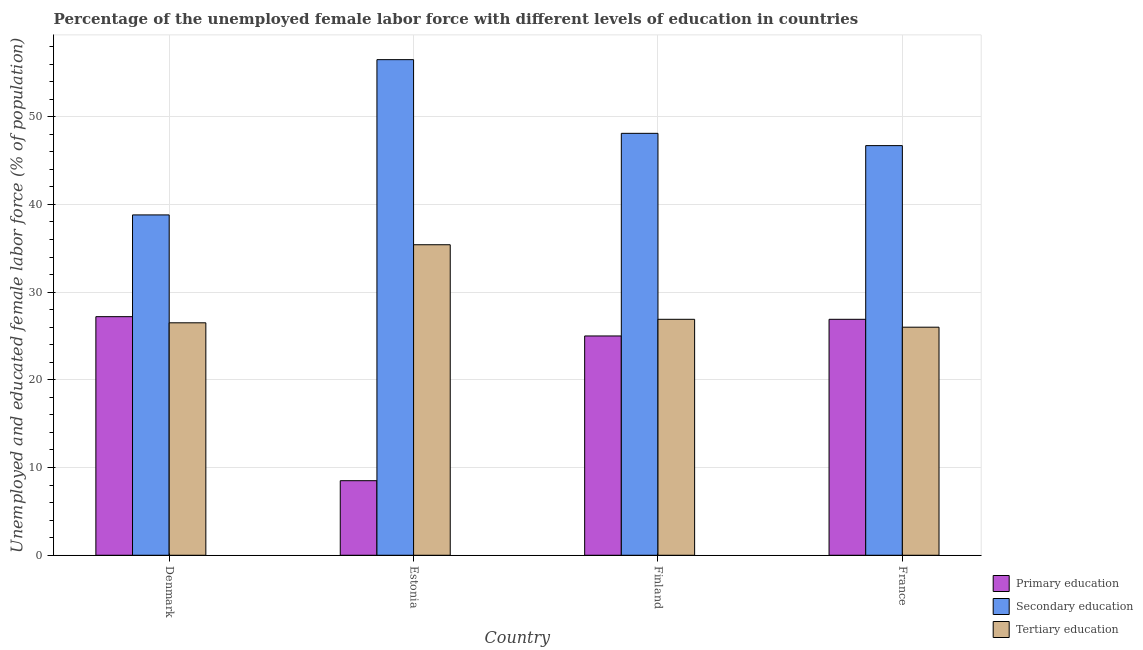Are the number of bars per tick equal to the number of legend labels?
Offer a very short reply. Yes. Are the number of bars on each tick of the X-axis equal?
Your answer should be compact. Yes. What is the label of the 4th group of bars from the left?
Your answer should be compact. France. What is the percentage of female labor force who received secondary education in Estonia?
Ensure brevity in your answer.  56.5. Across all countries, what is the maximum percentage of female labor force who received primary education?
Offer a terse response. 27.2. Across all countries, what is the minimum percentage of female labor force who received secondary education?
Provide a short and direct response. 38.8. In which country was the percentage of female labor force who received secondary education maximum?
Make the answer very short. Estonia. In which country was the percentage of female labor force who received secondary education minimum?
Keep it short and to the point. Denmark. What is the total percentage of female labor force who received primary education in the graph?
Ensure brevity in your answer.  87.6. What is the difference between the percentage of female labor force who received secondary education in Estonia and that in France?
Ensure brevity in your answer.  9.8. What is the difference between the percentage of female labor force who received secondary education in Denmark and the percentage of female labor force who received primary education in Estonia?
Your answer should be very brief. 30.3. What is the average percentage of female labor force who received primary education per country?
Provide a short and direct response. 21.9. What is the difference between the percentage of female labor force who received secondary education and percentage of female labor force who received primary education in Finland?
Provide a succinct answer. 23.1. What is the ratio of the percentage of female labor force who received tertiary education in Estonia to that in France?
Offer a very short reply. 1.36. Is the difference between the percentage of female labor force who received tertiary education in Denmark and Estonia greater than the difference between the percentage of female labor force who received secondary education in Denmark and Estonia?
Your answer should be compact. Yes. What is the difference between the highest and the second highest percentage of female labor force who received primary education?
Provide a succinct answer. 0.3. What is the difference between the highest and the lowest percentage of female labor force who received primary education?
Make the answer very short. 18.7. In how many countries, is the percentage of female labor force who received secondary education greater than the average percentage of female labor force who received secondary education taken over all countries?
Your answer should be compact. 2. Is the sum of the percentage of female labor force who received secondary education in Denmark and France greater than the maximum percentage of female labor force who received primary education across all countries?
Your answer should be compact. Yes. What does the 2nd bar from the left in Estonia represents?
Your answer should be compact. Secondary education. What does the 1st bar from the right in Estonia represents?
Provide a short and direct response. Tertiary education. Is it the case that in every country, the sum of the percentage of female labor force who received primary education and percentage of female labor force who received secondary education is greater than the percentage of female labor force who received tertiary education?
Provide a succinct answer. Yes. Are all the bars in the graph horizontal?
Provide a short and direct response. No. What is the difference between two consecutive major ticks on the Y-axis?
Offer a terse response. 10. Are the values on the major ticks of Y-axis written in scientific E-notation?
Your answer should be very brief. No. Where does the legend appear in the graph?
Offer a very short reply. Bottom right. How many legend labels are there?
Give a very brief answer. 3. How are the legend labels stacked?
Keep it short and to the point. Vertical. What is the title of the graph?
Make the answer very short. Percentage of the unemployed female labor force with different levels of education in countries. Does "Grants" appear as one of the legend labels in the graph?
Provide a short and direct response. No. What is the label or title of the Y-axis?
Offer a terse response. Unemployed and educated female labor force (% of population). What is the Unemployed and educated female labor force (% of population) of Primary education in Denmark?
Provide a succinct answer. 27.2. What is the Unemployed and educated female labor force (% of population) of Secondary education in Denmark?
Give a very brief answer. 38.8. What is the Unemployed and educated female labor force (% of population) in Secondary education in Estonia?
Your response must be concise. 56.5. What is the Unemployed and educated female labor force (% of population) in Tertiary education in Estonia?
Provide a short and direct response. 35.4. What is the Unemployed and educated female labor force (% of population) in Primary education in Finland?
Provide a short and direct response. 25. What is the Unemployed and educated female labor force (% of population) of Secondary education in Finland?
Your response must be concise. 48.1. What is the Unemployed and educated female labor force (% of population) in Tertiary education in Finland?
Ensure brevity in your answer.  26.9. What is the Unemployed and educated female labor force (% of population) in Primary education in France?
Ensure brevity in your answer.  26.9. What is the Unemployed and educated female labor force (% of population) of Secondary education in France?
Offer a terse response. 46.7. What is the Unemployed and educated female labor force (% of population) in Tertiary education in France?
Provide a succinct answer. 26. Across all countries, what is the maximum Unemployed and educated female labor force (% of population) in Primary education?
Provide a succinct answer. 27.2. Across all countries, what is the maximum Unemployed and educated female labor force (% of population) of Secondary education?
Offer a very short reply. 56.5. Across all countries, what is the maximum Unemployed and educated female labor force (% of population) in Tertiary education?
Your response must be concise. 35.4. Across all countries, what is the minimum Unemployed and educated female labor force (% of population) of Primary education?
Keep it short and to the point. 8.5. Across all countries, what is the minimum Unemployed and educated female labor force (% of population) in Secondary education?
Give a very brief answer. 38.8. Across all countries, what is the minimum Unemployed and educated female labor force (% of population) of Tertiary education?
Provide a succinct answer. 26. What is the total Unemployed and educated female labor force (% of population) in Primary education in the graph?
Ensure brevity in your answer.  87.6. What is the total Unemployed and educated female labor force (% of population) of Secondary education in the graph?
Offer a very short reply. 190.1. What is the total Unemployed and educated female labor force (% of population) of Tertiary education in the graph?
Offer a terse response. 114.8. What is the difference between the Unemployed and educated female labor force (% of population) in Primary education in Denmark and that in Estonia?
Provide a succinct answer. 18.7. What is the difference between the Unemployed and educated female labor force (% of population) of Secondary education in Denmark and that in Estonia?
Offer a terse response. -17.7. What is the difference between the Unemployed and educated female labor force (% of population) of Tertiary education in Denmark and that in Estonia?
Ensure brevity in your answer.  -8.9. What is the difference between the Unemployed and educated female labor force (% of population) of Tertiary education in Denmark and that in Finland?
Offer a terse response. -0.4. What is the difference between the Unemployed and educated female labor force (% of population) of Primary education in Denmark and that in France?
Offer a terse response. 0.3. What is the difference between the Unemployed and educated female labor force (% of population) of Tertiary education in Denmark and that in France?
Keep it short and to the point. 0.5. What is the difference between the Unemployed and educated female labor force (% of population) in Primary education in Estonia and that in Finland?
Provide a short and direct response. -16.5. What is the difference between the Unemployed and educated female labor force (% of population) of Secondary education in Estonia and that in Finland?
Offer a terse response. 8.4. What is the difference between the Unemployed and educated female labor force (% of population) of Tertiary education in Estonia and that in Finland?
Your answer should be compact. 8.5. What is the difference between the Unemployed and educated female labor force (% of population) of Primary education in Estonia and that in France?
Provide a short and direct response. -18.4. What is the difference between the Unemployed and educated female labor force (% of population) of Tertiary education in Estonia and that in France?
Your response must be concise. 9.4. What is the difference between the Unemployed and educated female labor force (% of population) of Primary education in Finland and that in France?
Keep it short and to the point. -1.9. What is the difference between the Unemployed and educated female labor force (% of population) in Secondary education in Finland and that in France?
Your answer should be compact. 1.4. What is the difference between the Unemployed and educated female labor force (% of population) of Primary education in Denmark and the Unemployed and educated female labor force (% of population) of Secondary education in Estonia?
Ensure brevity in your answer.  -29.3. What is the difference between the Unemployed and educated female labor force (% of population) in Secondary education in Denmark and the Unemployed and educated female labor force (% of population) in Tertiary education in Estonia?
Offer a very short reply. 3.4. What is the difference between the Unemployed and educated female labor force (% of population) in Primary education in Denmark and the Unemployed and educated female labor force (% of population) in Secondary education in Finland?
Offer a very short reply. -20.9. What is the difference between the Unemployed and educated female labor force (% of population) in Primary education in Denmark and the Unemployed and educated female labor force (% of population) in Tertiary education in Finland?
Your response must be concise. 0.3. What is the difference between the Unemployed and educated female labor force (% of population) of Secondary education in Denmark and the Unemployed and educated female labor force (% of population) of Tertiary education in Finland?
Offer a very short reply. 11.9. What is the difference between the Unemployed and educated female labor force (% of population) in Primary education in Denmark and the Unemployed and educated female labor force (% of population) in Secondary education in France?
Your response must be concise. -19.5. What is the difference between the Unemployed and educated female labor force (% of population) in Primary education in Denmark and the Unemployed and educated female labor force (% of population) in Tertiary education in France?
Give a very brief answer. 1.2. What is the difference between the Unemployed and educated female labor force (% of population) in Primary education in Estonia and the Unemployed and educated female labor force (% of population) in Secondary education in Finland?
Keep it short and to the point. -39.6. What is the difference between the Unemployed and educated female labor force (% of population) of Primary education in Estonia and the Unemployed and educated female labor force (% of population) of Tertiary education in Finland?
Make the answer very short. -18.4. What is the difference between the Unemployed and educated female labor force (% of population) of Secondary education in Estonia and the Unemployed and educated female labor force (% of population) of Tertiary education in Finland?
Give a very brief answer. 29.6. What is the difference between the Unemployed and educated female labor force (% of population) of Primary education in Estonia and the Unemployed and educated female labor force (% of population) of Secondary education in France?
Give a very brief answer. -38.2. What is the difference between the Unemployed and educated female labor force (% of population) in Primary education in Estonia and the Unemployed and educated female labor force (% of population) in Tertiary education in France?
Your answer should be very brief. -17.5. What is the difference between the Unemployed and educated female labor force (% of population) in Secondary education in Estonia and the Unemployed and educated female labor force (% of population) in Tertiary education in France?
Provide a short and direct response. 30.5. What is the difference between the Unemployed and educated female labor force (% of population) in Primary education in Finland and the Unemployed and educated female labor force (% of population) in Secondary education in France?
Make the answer very short. -21.7. What is the difference between the Unemployed and educated female labor force (% of population) of Primary education in Finland and the Unemployed and educated female labor force (% of population) of Tertiary education in France?
Provide a succinct answer. -1. What is the difference between the Unemployed and educated female labor force (% of population) in Secondary education in Finland and the Unemployed and educated female labor force (% of population) in Tertiary education in France?
Keep it short and to the point. 22.1. What is the average Unemployed and educated female labor force (% of population) in Primary education per country?
Ensure brevity in your answer.  21.9. What is the average Unemployed and educated female labor force (% of population) in Secondary education per country?
Give a very brief answer. 47.52. What is the average Unemployed and educated female labor force (% of population) in Tertiary education per country?
Offer a very short reply. 28.7. What is the difference between the Unemployed and educated female labor force (% of population) of Primary education and Unemployed and educated female labor force (% of population) of Secondary education in Estonia?
Offer a terse response. -48. What is the difference between the Unemployed and educated female labor force (% of population) in Primary education and Unemployed and educated female labor force (% of population) in Tertiary education in Estonia?
Keep it short and to the point. -26.9. What is the difference between the Unemployed and educated female labor force (% of population) of Secondary education and Unemployed and educated female labor force (% of population) of Tertiary education in Estonia?
Offer a terse response. 21.1. What is the difference between the Unemployed and educated female labor force (% of population) in Primary education and Unemployed and educated female labor force (% of population) in Secondary education in Finland?
Make the answer very short. -23.1. What is the difference between the Unemployed and educated female labor force (% of population) of Primary education and Unemployed and educated female labor force (% of population) of Tertiary education in Finland?
Your answer should be very brief. -1.9. What is the difference between the Unemployed and educated female labor force (% of population) of Secondary education and Unemployed and educated female labor force (% of population) of Tertiary education in Finland?
Your response must be concise. 21.2. What is the difference between the Unemployed and educated female labor force (% of population) of Primary education and Unemployed and educated female labor force (% of population) of Secondary education in France?
Your response must be concise. -19.8. What is the difference between the Unemployed and educated female labor force (% of population) in Primary education and Unemployed and educated female labor force (% of population) in Tertiary education in France?
Make the answer very short. 0.9. What is the difference between the Unemployed and educated female labor force (% of population) in Secondary education and Unemployed and educated female labor force (% of population) in Tertiary education in France?
Provide a short and direct response. 20.7. What is the ratio of the Unemployed and educated female labor force (% of population) of Secondary education in Denmark to that in Estonia?
Provide a short and direct response. 0.69. What is the ratio of the Unemployed and educated female labor force (% of population) in Tertiary education in Denmark to that in Estonia?
Make the answer very short. 0.75. What is the ratio of the Unemployed and educated female labor force (% of population) of Primary education in Denmark to that in Finland?
Provide a succinct answer. 1.09. What is the ratio of the Unemployed and educated female labor force (% of population) in Secondary education in Denmark to that in Finland?
Provide a short and direct response. 0.81. What is the ratio of the Unemployed and educated female labor force (% of population) of Tertiary education in Denmark to that in Finland?
Your answer should be compact. 0.99. What is the ratio of the Unemployed and educated female labor force (% of population) of Primary education in Denmark to that in France?
Offer a terse response. 1.01. What is the ratio of the Unemployed and educated female labor force (% of population) in Secondary education in Denmark to that in France?
Offer a very short reply. 0.83. What is the ratio of the Unemployed and educated female labor force (% of population) in Tertiary education in Denmark to that in France?
Your answer should be very brief. 1.02. What is the ratio of the Unemployed and educated female labor force (% of population) in Primary education in Estonia to that in Finland?
Provide a short and direct response. 0.34. What is the ratio of the Unemployed and educated female labor force (% of population) in Secondary education in Estonia to that in Finland?
Your response must be concise. 1.17. What is the ratio of the Unemployed and educated female labor force (% of population) in Tertiary education in Estonia to that in Finland?
Your response must be concise. 1.32. What is the ratio of the Unemployed and educated female labor force (% of population) in Primary education in Estonia to that in France?
Give a very brief answer. 0.32. What is the ratio of the Unemployed and educated female labor force (% of population) in Secondary education in Estonia to that in France?
Your answer should be compact. 1.21. What is the ratio of the Unemployed and educated female labor force (% of population) of Tertiary education in Estonia to that in France?
Your answer should be compact. 1.36. What is the ratio of the Unemployed and educated female labor force (% of population) of Primary education in Finland to that in France?
Your response must be concise. 0.93. What is the ratio of the Unemployed and educated female labor force (% of population) in Secondary education in Finland to that in France?
Your response must be concise. 1.03. What is the ratio of the Unemployed and educated female labor force (% of population) of Tertiary education in Finland to that in France?
Ensure brevity in your answer.  1.03. What is the difference between the highest and the second highest Unemployed and educated female labor force (% of population) in Primary education?
Offer a terse response. 0.3. What is the difference between the highest and the lowest Unemployed and educated female labor force (% of population) in Secondary education?
Ensure brevity in your answer.  17.7. 